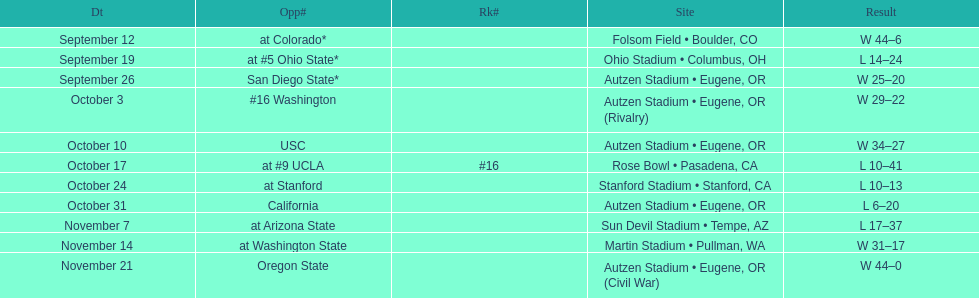Between september 26 and october 24, how many games were played in eugene, or? 3. 